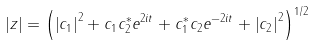<formula> <loc_0><loc_0><loc_500><loc_500>\left | z \right | = \left ( \left | c _ { 1 } \right | ^ { 2 } + c _ { 1 } c _ { 2 } ^ { \ast } e ^ { 2 i t } + c _ { 1 } ^ { \ast } c _ { 2 } e ^ { - 2 i t } + \left | c _ { 2 } \right | ^ { 2 } \right ) ^ { 1 / 2 }</formula> 